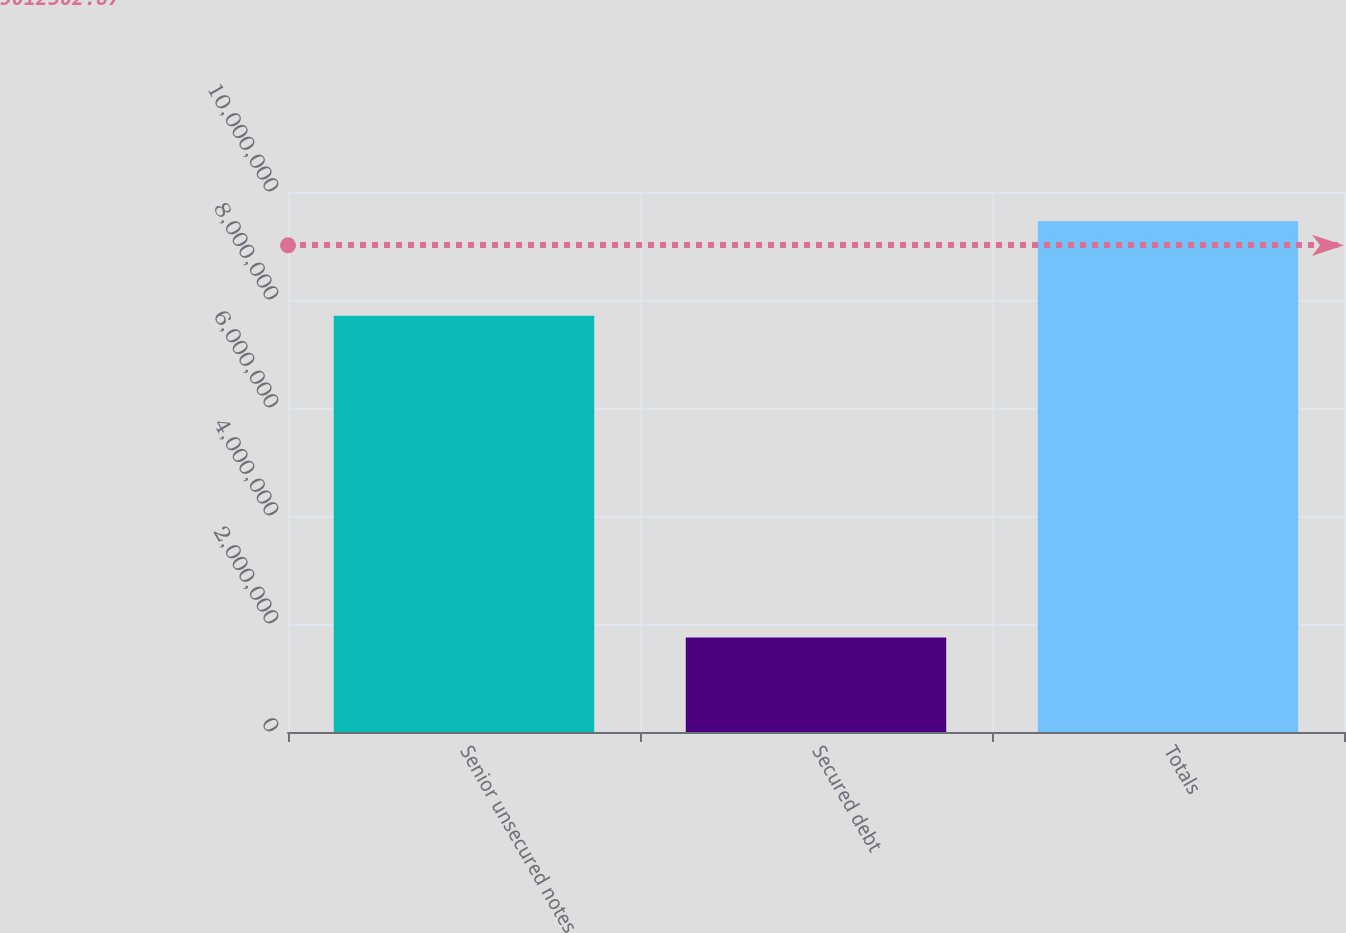Convert chart to OTSL. <chart><loc_0><loc_0><loc_500><loc_500><bar_chart><fcel>Senior unsecured notes<fcel>Secured debt<fcel>Totals<nl><fcel>7.71022e+06<fcel>1.74996e+06<fcel>9.46018e+06<nl></chart> 